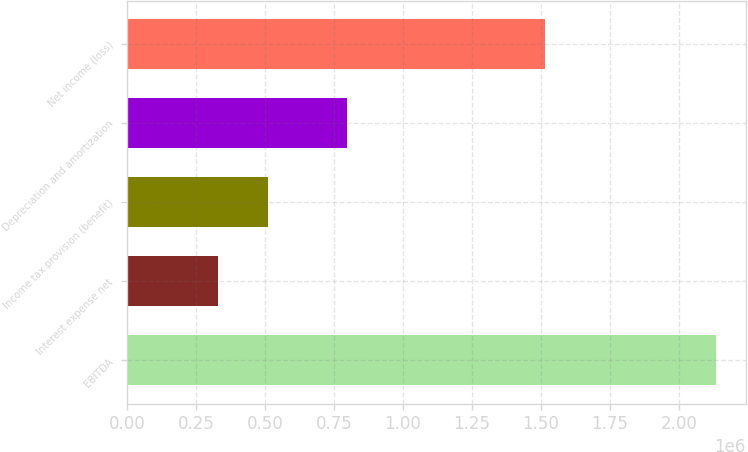<chart> <loc_0><loc_0><loc_500><loc_500><bar_chart><fcel>EBITDA<fcel>Interest expense net<fcel>Income tax provision (benefit)<fcel>Depreciation and amortization<fcel>Net income (loss)<nl><fcel>2.13531e+06<fcel>330326<fcel>510824<fcel>797892<fcel>1.51454e+06<nl></chart> 